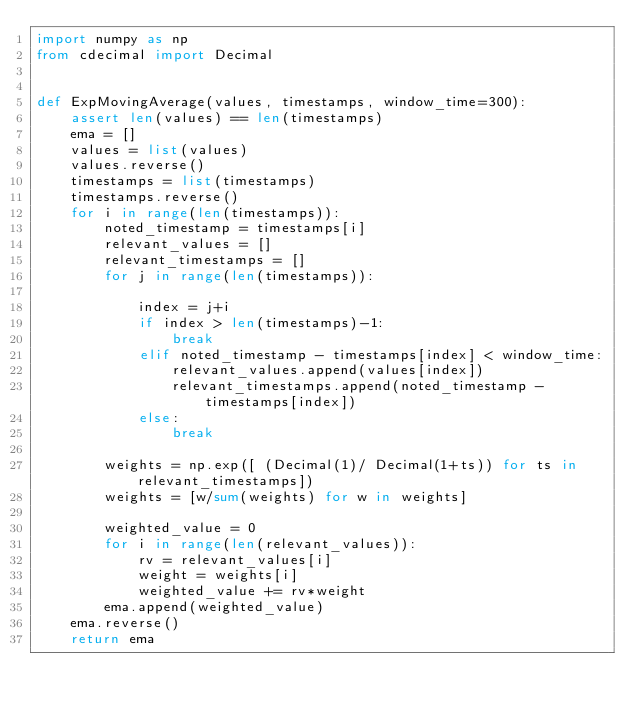Convert code to text. <code><loc_0><loc_0><loc_500><loc_500><_Python_>import numpy as np
from cdecimal import Decimal


def ExpMovingAverage(values, timestamps, window_time=300):
    assert len(values) == len(timestamps)
    ema = []
    values = list(values)
    values.reverse()
    timestamps = list(timestamps)
    timestamps.reverse()
    for i in range(len(timestamps)):
        noted_timestamp = timestamps[i]
        relevant_values = []
        relevant_timestamps = []
        for j in range(len(timestamps)):
            
            index = j+i
            if index > len(timestamps)-1:
                break 
            elif noted_timestamp - timestamps[index] < window_time:
                relevant_values.append(values[index])
                relevant_timestamps.append(noted_timestamp - timestamps[index])
            else:
                break
            
        weights = np.exp([ (Decimal(1)/ Decimal(1+ts)) for ts in relevant_timestamps])
        weights = [w/sum(weights) for w in weights]
        
        weighted_value = 0
        for i in range(len(relevant_values)):
            rv = relevant_values[i]
            weight = weights[i]
            weighted_value += rv*weight
        ema.append(weighted_value)
    ema.reverse()
    return ema
</code> 